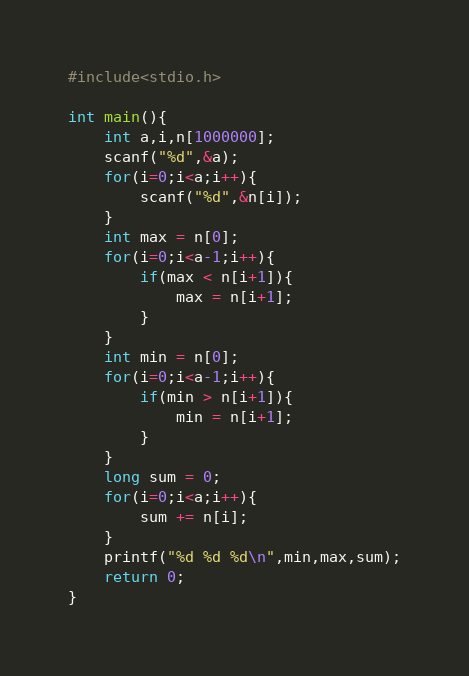Convert code to text. <code><loc_0><loc_0><loc_500><loc_500><_C_>#include<stdio.h>

int main(){
    int a,i,n[1000000];
    scanf("%d",&a);
    for(i=0;i<a;i++){
        scanf("%d",&n[i]);
    }
    int max = n[0];
    for(i=0;i<a-1;i++){
        if(max < n[i+1]){
            max = n[i+1];
        }
    }
    int min = n[0];
    for(i=0;i<a-1;i++){
        if(min > n[i+1]){
            min = n[i+1];
        }
    }
    long sum = 0;
    for(i=0;i<a;i++){
        sum += n[i];
    }
    printf("%d %d %d\n",min,max,sum);
    return 0;
}


</code> 